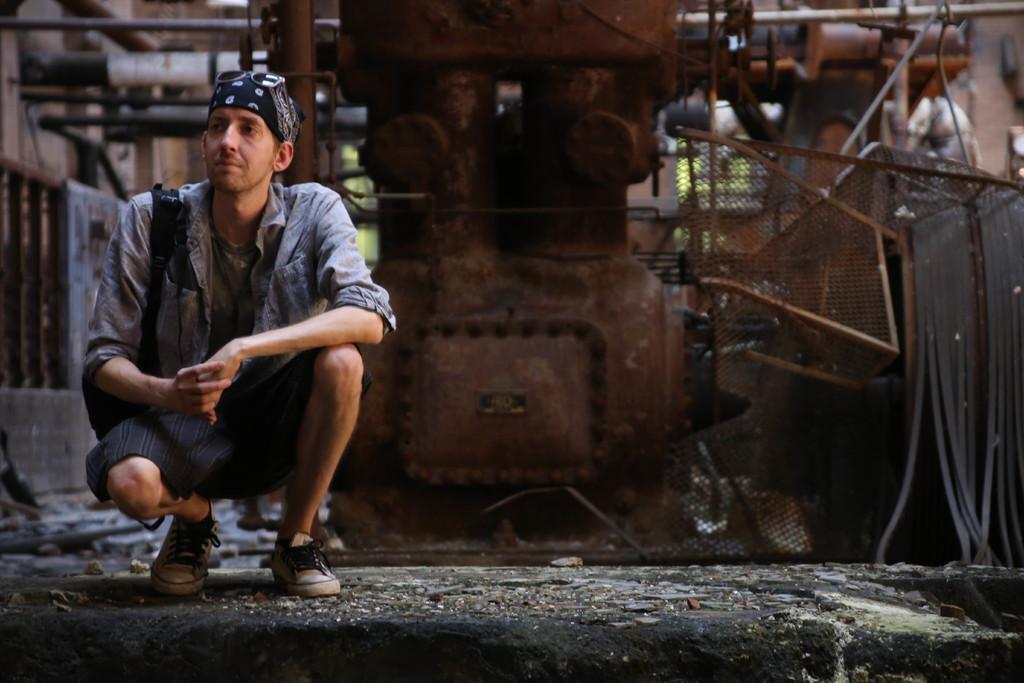Describe this image in one or two sentences. On the left side, we see a man is wearing a black bag and he is in squad position. Behind him, we see a transformer and the fence. At the bottom, we see the pavement. On the left side, we see the iron railing. There are poles, iron rods and trees in the background. This picture is blurred in the background. 